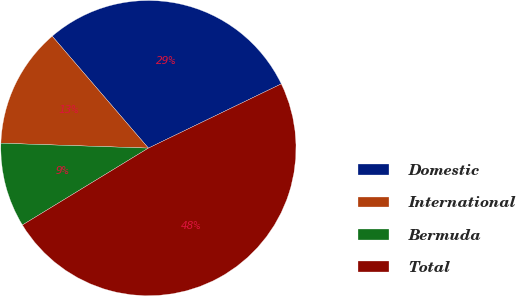Convert chart. <chart><loc_0><loc_0><loc_500><loc_500><pie_chart><fcel>Domestic<fcel>International<fcel>Bermuda<fcel>Total<nl><fcel>29.13%<fcel>13.17%<fcel>9.25%<fcel>48.44%<nl></chart> 